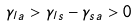Convert formula to latex. <formula><loc_0><loc_0><loc_500><loc_500>\gamma _ { l a } > \gamma _ { l s } - \gamma _ { s a } > 0</formula> 